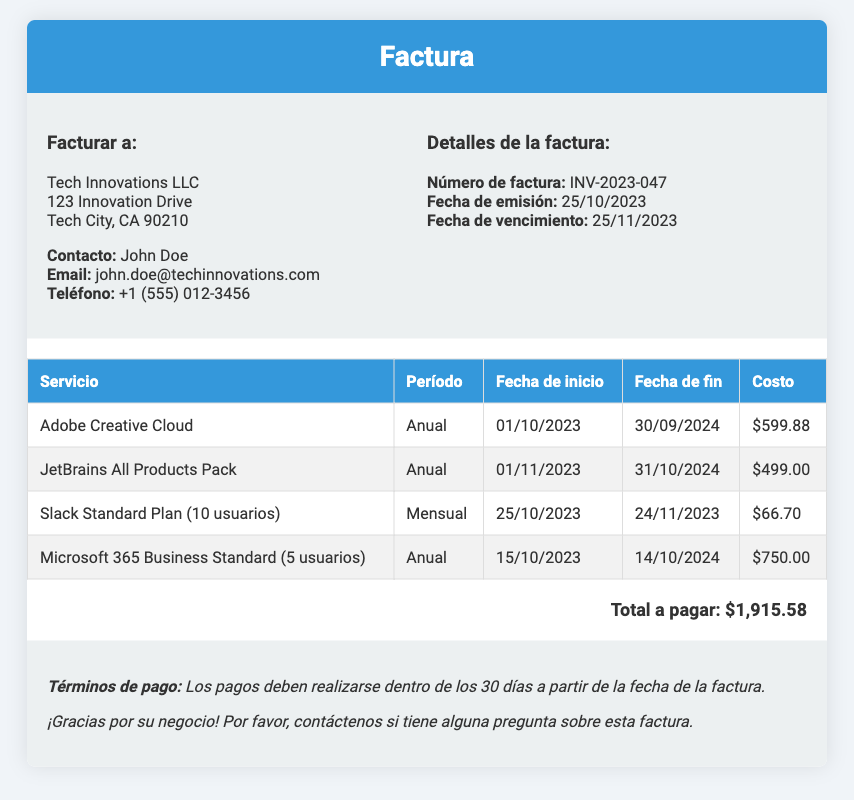¿Cuál es el número de la factura? El número de la factura se presenta claramente en la sección de detalles de la factura.
Answer: INV-2023-047 ¿Cuál es el total a pagar? El total a pagar es el resultado de la suma de todos los costos listados en la factura.
Answer: $1,915.58 ¿Cuál es el costo del plan de Microsoft 365 Business Standard? El costo del plan se detalla en la tabla de servicios y sus costos.
Answer: $750.00 ¿Cuál es la fecha de inicio del servicio de Slack Standard Plan? La fecha de inicio de este servicio está especificada en la tabla de la factura.
Answer: 25/10/2023 ¿Cuánto tiempo cubre cada suscripción de Adobe Creative Cloud? La duración de la suscripción está indicada en la tabla como anual.
Answer: Anual ¿Qué servicio tiene un costo mensual? Se requiere identificar el servicio que tiene un período de facturación mensual en la tabla.
Answer: Slack Standard Plan (10 usuarios) ¿Cuándo es la fecha de vencimiento de la factura? La fecha de vencimiento es importante para los términos de pago y se encuentra en la sección de detalles de la factura.
Answer: 25/11/2023 ¿Cuántos usuarios están incluidos en el plan de Slack? El número de usuarios incluidos en este servicio se detalla en la tabla.
Answer: 10 usuarios ¿A quién se facturó? El nombre del cliente que se ha facturado se menciona en el encabezado de la sección de facturación.
Answer: Tech Innovations LLC 